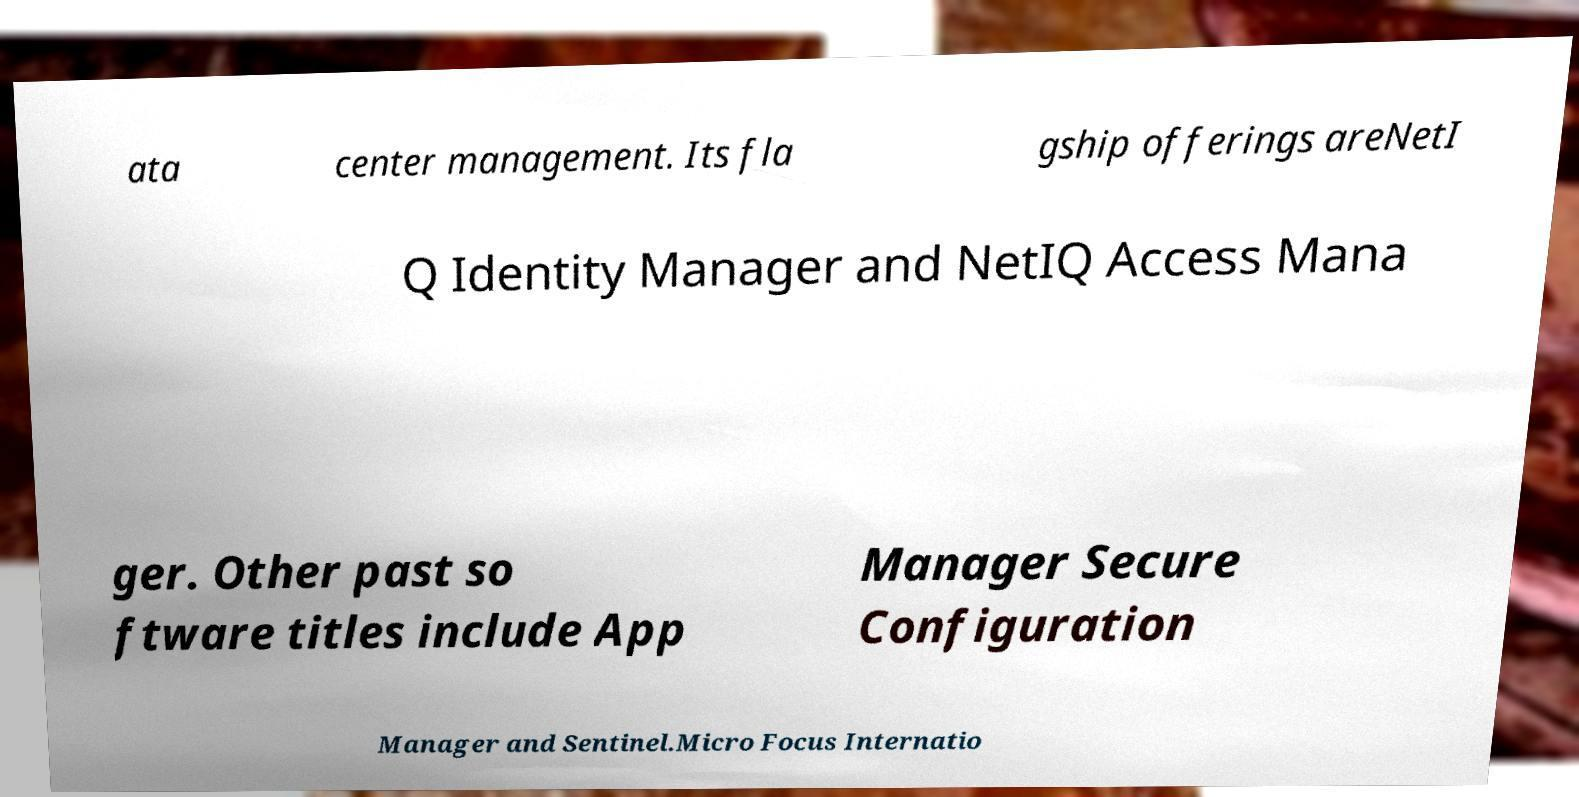Could you assist in decoding the text presented in this image and type it out clearly? ata center management. Its fla gship offerings areNetI Q Identity Manager and NetIQ Access Mana ger. Other past so ftware titles include App Manager Secure Configuration Manager and Sentinel.Micro Focus Internatio 